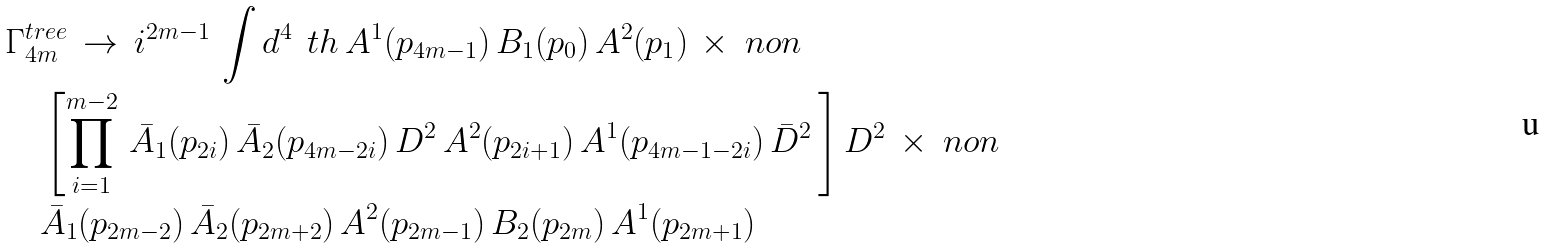<formula> <loc_0><loc_0><loc_500><loc_500>& { \Gamma } ^ { t r e e } _ { 4 m } \, \rightarrow \, i ^ { 2 m - 1 } \, \int d ^ { 4 } \, \ t h \, A ^ { 1 } ( p _ { 4 m - 1 } ) \, B _ { 1 } ( p _ { 0 } ) \, A ^ { 2 } ( p _ { 1 } ) \, \times \ n o n \\ & \quad \left [ \prod _ { i = 1 } ^ { m - 2 } \, \bar { A } _ { 1 } ( p _ { 2 i } ) \, \bar { A } _ { 2 } ( p _ { 4 m - 2 i } ) \, D ^ { 2 } \, A ^ { 2 } ( p _ { 2 i + 1 } ) \, A ^ { 1 } ( p _ { 4 m - 1 - 2 i } ) \, \bar { D } ^ { 2 } \, \right ] D ^ { 2 } \, \times \ n o n \\ & \quad \bar { A } _ { 1 } ( p _ { 2 m - 2 } ) \, \bar { A } _ { 2 } ( p _ { 2 m + 2 } ) \, A ^ { 2 } ( p _ { 2 m - 1 } ) \, B _ { 2 } ( p _ { 2 m } ) \, A ^ { 1 } ( p _ { 2 m + 1 } ) \,</formula> 